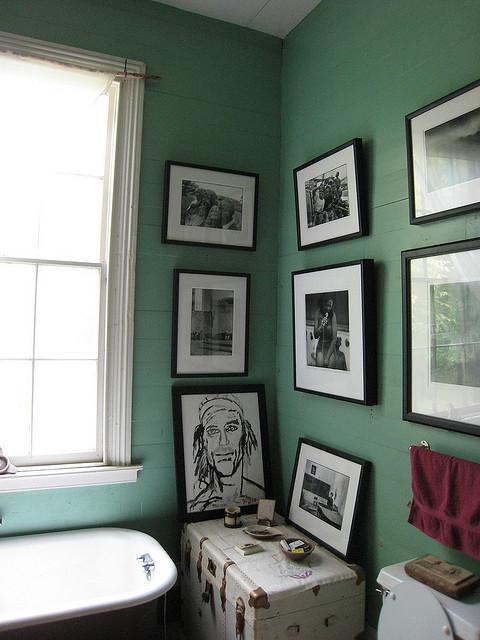Is the paper stripped?
Give a very brief answer. No. Can you see the eyes in the portrait?
Give a very brief answer. Yes. What is on the window seal?
Give a very brief answer. Nothing. What colors are the towel that's hanging?
Keep it brief. Red. Why are the blinds raised on the window?
Write a very short answer. Sunlight. Is there an open window?
Short answer required. No. What is the middle painting portraying?
Give a very brief answer. Woman. What color are the towels?
Quick response, please. Red. Is the toilet seat up or down?
Keep it brief. Down. What is the main color of this room?
Concise answer only. Green. What picture is on the portrait?
Concise answer only. Man. What color is the wall?
Short answer required. Green. How many pictures are on the wall?
Concise answer only. 8. Is this a modern bathroom?
Be succinct. Yes. Is the door to this room shown in the picture?
Give a very brief answer. No. What sort of photograph dominates the wall to the right of the toilet?
Keep it brief. Retro. What are the large white objects on the wall?
Quick response, please. Pictures. 